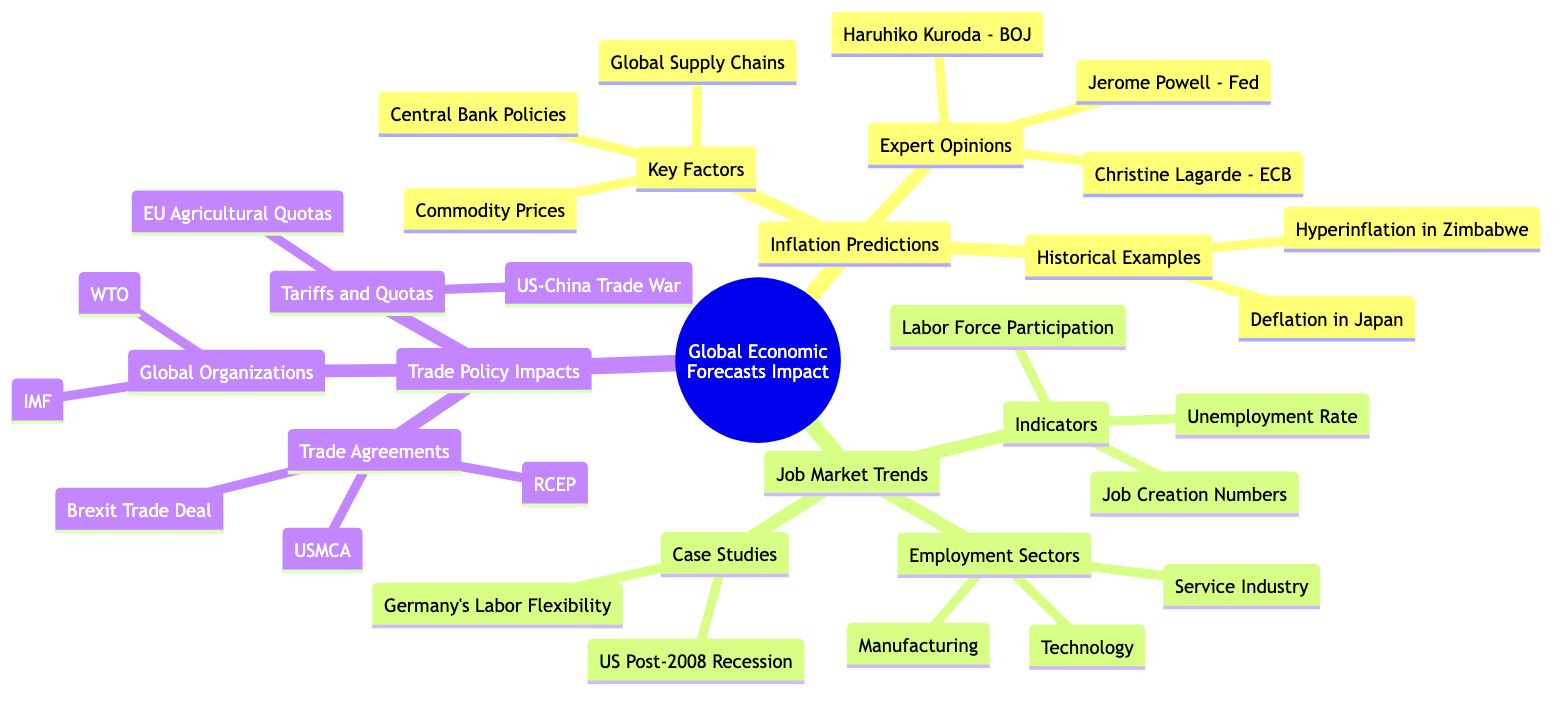What are the key factors influencing inflation predictions? The diagram lists three key factors under the "Inflation Predictions" node, which are "Central Bank Policies," "Commodity Prices," and "Global Supply Chains."
Answer: Central Bank Policies, Commodity Prices, Global Supply Chains Which expert opinions are cited regarding inflation? Under the "Expert Opinions" node, three individuals are mentioned: "Christine Lagarde - ECB," "Jerome Powell - Federal Reserve," and "Haruhiko Kuroda - Bank of Japan."
Answer: Christine Lagarde - ECB, Jerome Powell - Fed, Haruhiko Kuroda - BOJ How many employment sectors are identified in the job market trends? The "Employment Sectors" node lists three areas: "Manufacturing," "Technology," and "Service Industry." Counting these gives us three sectors.
Answer: 3 What historical example is provided related to extreme inflation? The "Historical Examples" node mentions "Hyperinflation in Zimbabwe" as a notable example of extreme inflation.
Answer: Hyperinflation in Zimbabwe Which trade agreement is specifically mentioned under trade policy impacts? The "Trade Agreements" node lists three agreements, and one specifically mentioned is "USMCA."
Answer: USMCA What is the unemployment rate considered in the job market trends section? The "Indicators" node includes "Unemployment Rate," which indicates its relevance in assessing job market trends.
Answer: Unemployment Rate How do tariffs and quotas affect trade policy? The "Tariffs and Quotas" node mentions "US-China Trade War" and "EU Agricultural Quotas," indicating the impact of such measures on trade policy.
Answer: US-China Trade War, EU Agricultural Quotas What case studies are highlighted in the job market trends? The "Case Studies" node lists two specific cases: "U.S. Job Market Post-2008 Recession" and "Germany's Labor Market Flexibility."
Answer: U.S. Job Market Post-2008 Recession, Germany's Labor Flexibility Which global organization is mentioned in the context of trade policy? Under the "Global Trade Organizations" node, "World Trade Organization (WTO)" is specifically mentioned as a key player in trade policy.
Answer: World Trade Organization (WTO) 